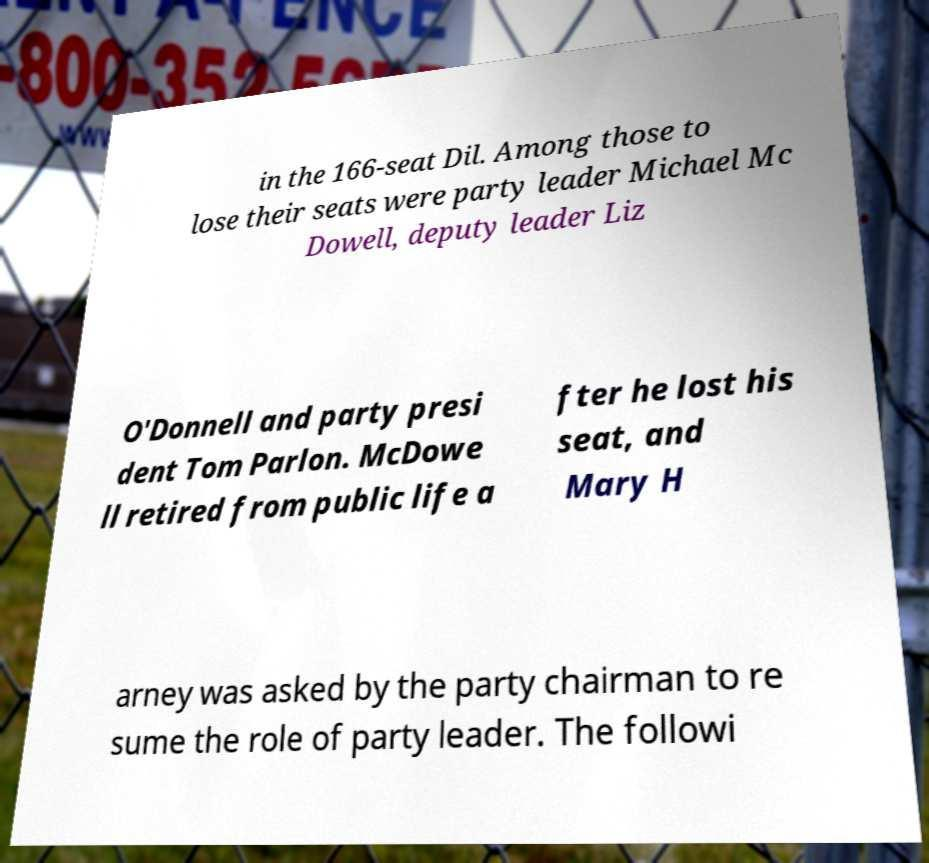Please read and relay the text visible in this image. What does it say? in the 166-seat Dil. Among those to lose their seats were party leader Michael Mc Dowell, deputy leader Liz O'Donnell and party presi dent Tom Parlon. McDowe ll retired from public life a fter he lost his seat, and Mary H arney was asked by the party chairman to re sume the role of party leader. The followi 